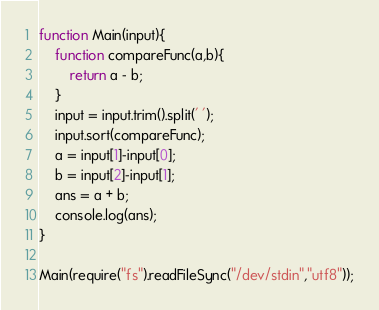<code> <loc_0><loc_0><loc_500><loc_500><_JavaScript_>function Main(input){
	function compareFunc(a,b){
    	return a - b;
    }
    input = input.trim().split(' ');
    input.sort(compareFunc);
    a = input[1]-input[0];
    b = input[2]-input[1];
    ans = a + b;
    console.log(ans);
}

Main(require("fs").readFileSync("/dev/stdin","utf8"));</code> 